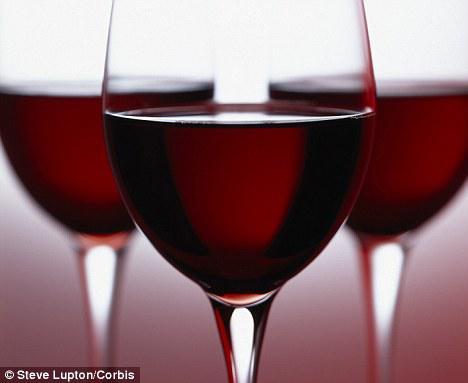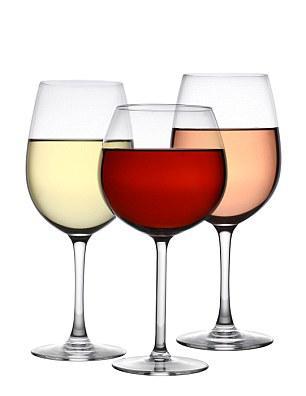The first image is the image on the left, the second image is the image on the right. For the images displayed, is the sentence "An image includes a trio of stemmed glasses all containing red wine, with the middle glass in front of the other two." factually correct? Answer yes or no. Yes. 